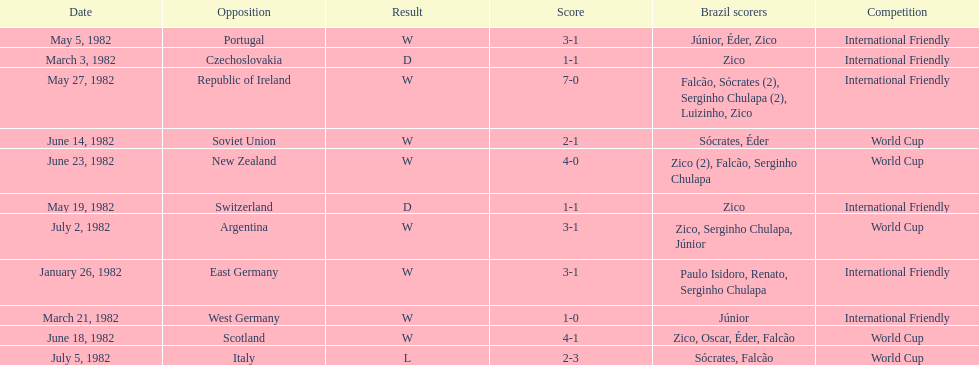What date is at the top of the list? January 26, 1982. 